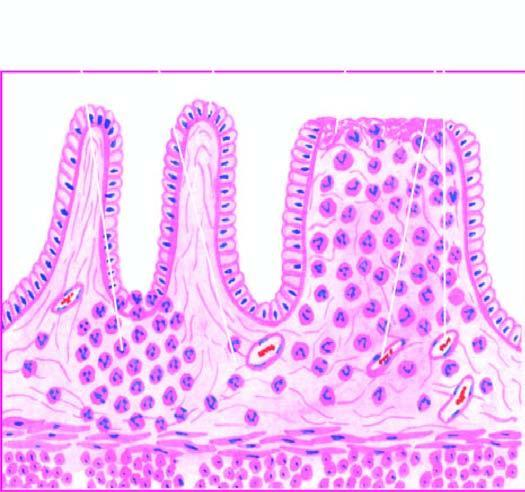how are the microscopic features seen superficial ulcerations?
Answer the question using a single word or phrase. With mucosal infiltration 